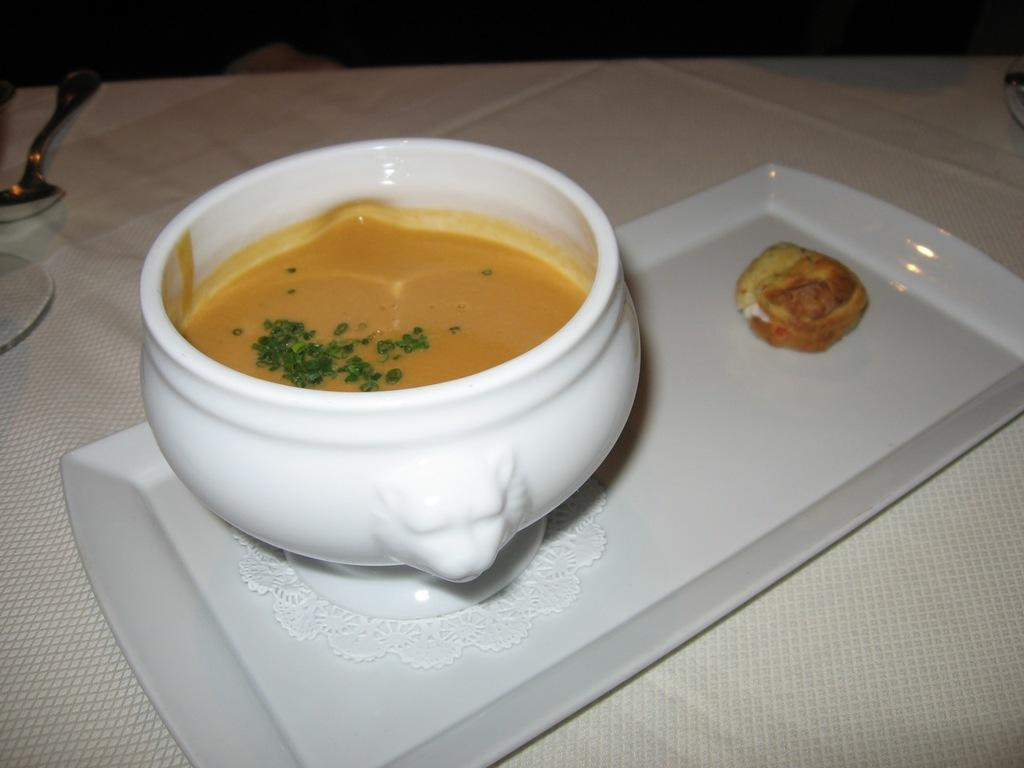What is located on the table in the image? There is a bowl and a tray with food items on the table in the image. What is the purpose of the bowl in the image? The purpose of the bowl in the image is to hold food items. What is the arrangement of the food items in the image? The food items are placed on a tray in the image. What type of club can be seen in the image? There is no club present in the image; it features a bowl and a tray with food items on a table. 